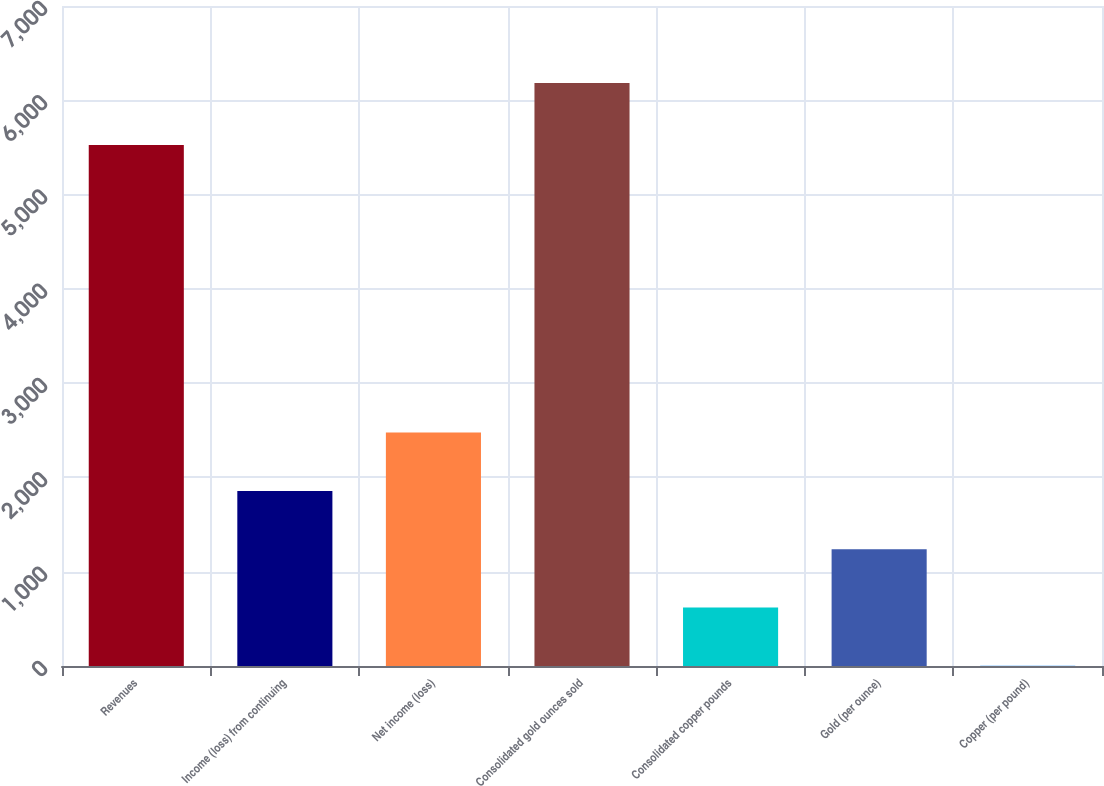Convert chart. <chart><loc_0><loc_0><loc_500><loc_500><bar_chart><fcel>Revenues<fcel>Income (loss) from continuing<fcel>Net income (loss)<fcel>Consolidated gold ounces sold<fcel>Consolidated copper pounds<fcel>Gold (per ounce)<fcel>Copper (per pound)<nl><fcel>5526<fcel>1857.19<fcel>2475.3<fcel>6184<fcel>620.97<fcel>1239.08<fcel>2.86<nl></chart> 